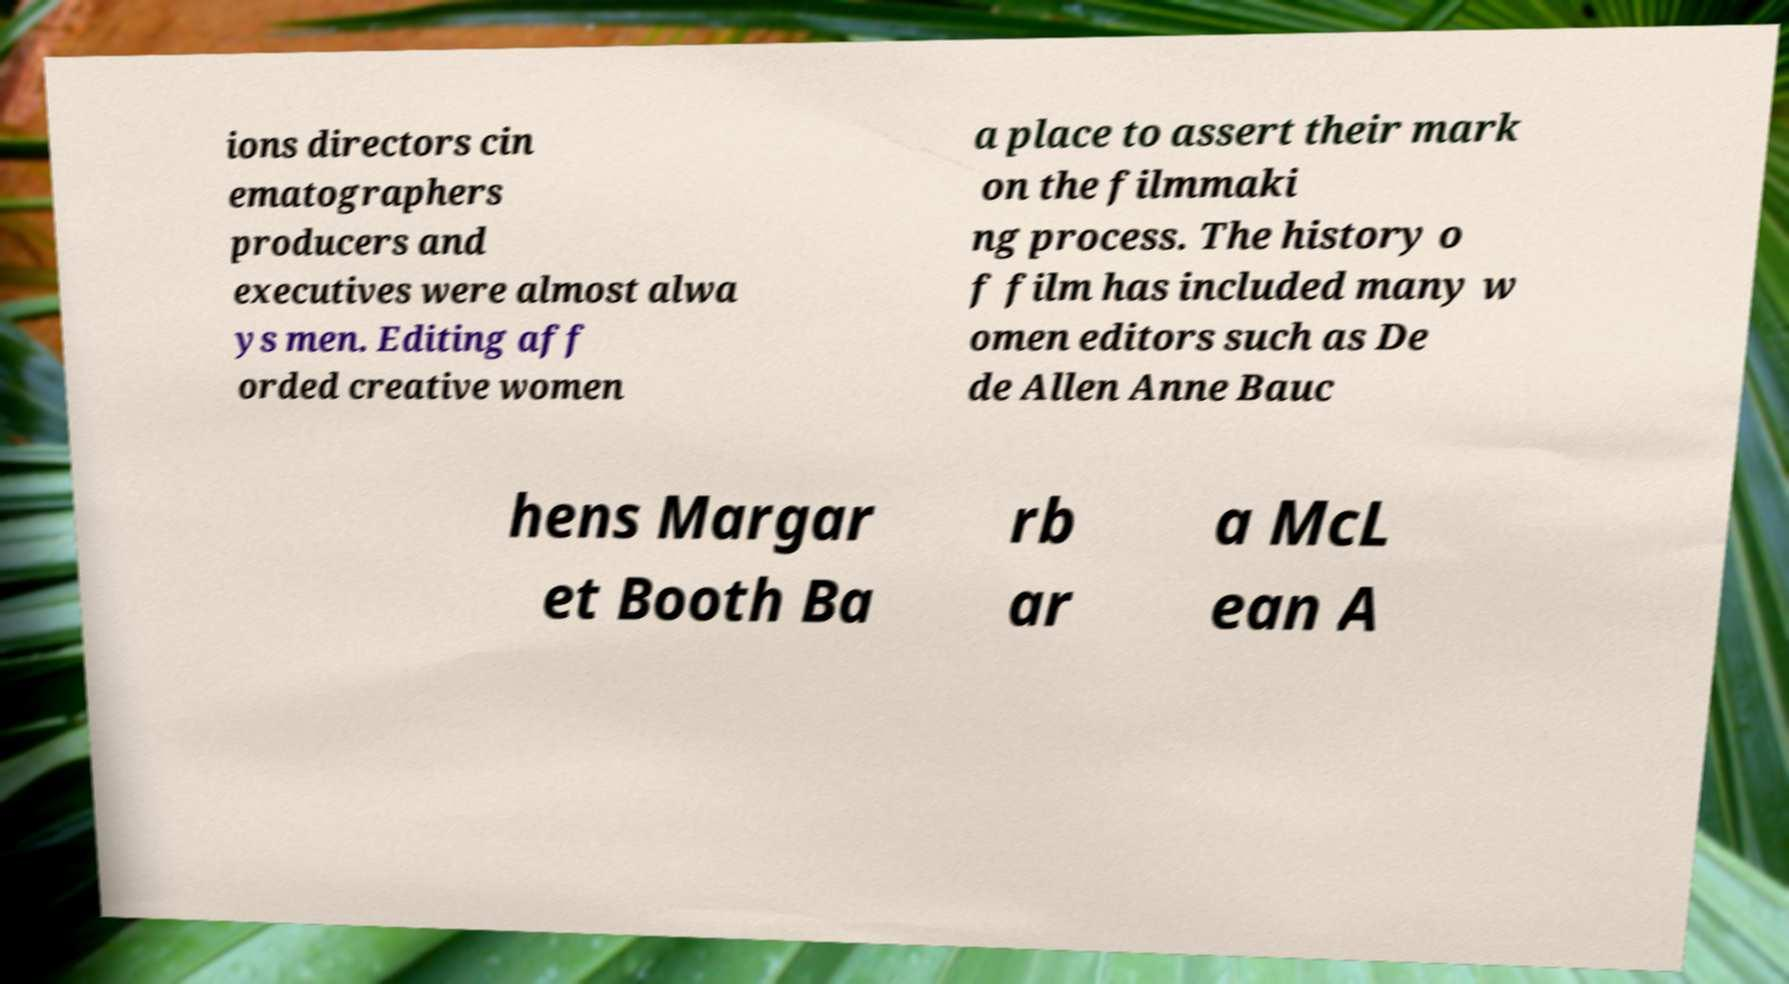What messages or text are displayed in this image? I need them in a readable, typed format. ions directors cin ematographers producers and executives were almost alwa ys men. Editing aff orded creative women a place to assert their mark on the filmmaki ng process. The history o f film has included many w omen editors such as De de Allen Anne Bauc hens Margar et Booth Ba rb ar a McL ean A 